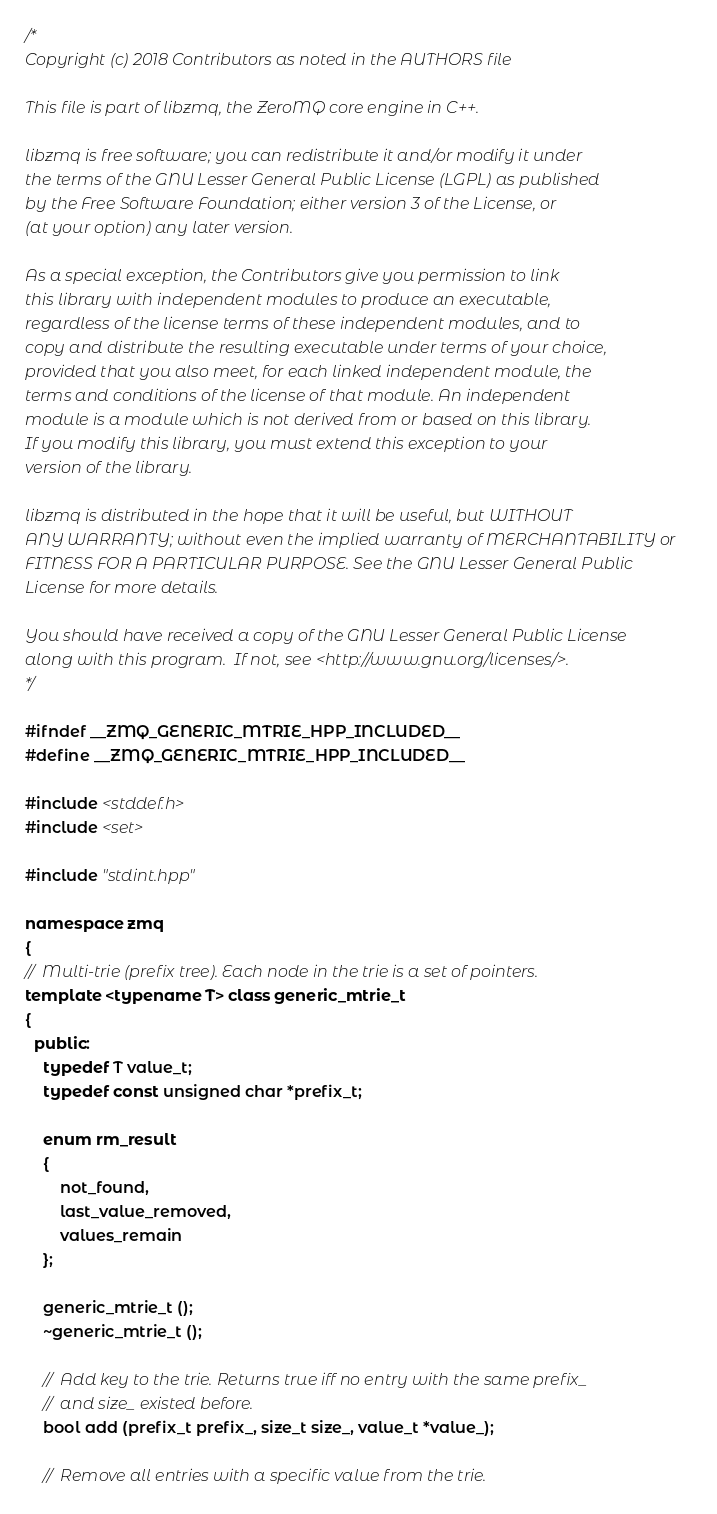Convert code to text. <code><loc_0><loc_0><loc_500><loc_500><_C++_>/*
Copyright (c) 2018 Contributors as noted in the AUTHORS file

This file is part of libzmq, the ZeroMQ core engine in C++.

libzmq is free software; you can redistribute it and/or modify it under
the terms of the GNU Lesser General Public License (LGPL) as published
by the Free Software Foundation; either version 3 of the License, or
(at your option) any later version.

As a special exception, the Contributors give you permission to link
this library with independent modules to produce an executable,
regardless of the license terms of these independent modules, and to
copy and distribute the resulting executable under terms of your choice,
provided that you also meet, for each linked independent module, the
terms and conditions of the license of that module. An independent
module is a module which is not derived from or based on this library.
If you modify this library, you must extend this exception to your
version of the library.

libzmq is distributed in the hope that it will be useful, but WITHOUT
ANY WARRANTY; without even the implied warranty of MERCHANTABILITY or
FITNESS FOR A PARTICULAR PURPOSE. See the GNU Lesser General Public
License for more details.

You should have received a copy of the GNU Lesser General Public License
along with this program.  If not, see <http://www.gnu.org/licenses/>.
*/

#ifndef __ZMQ_GENERIC_MTRIE_HPP_INCLUDED__
#define __ZMQ_GENERIC_MTRIE_HPP_INCLUDED__

#include <stddef.h>
#include <set>

#include "stdint.hpp"

namespace zmq
{
//  Multi-trie (prefix tree). Each node in the trie is a set of pointers.
template <typename T> class generic_mtrie_t
{
  public:
    typedef T value_t;
    typedef const unsigned char *prefix_t;

    enum rm_result
    {
        not_found,
        last_value_removed,
        values_remain
    };

    generic_mtrie_t ();
    ~generic_mtrie_t ();

    //  Add key to the trie. Returns true iff no entry with the same prefix_
    //  and size_ existed before.
    bool add (prefix_t prefix_, size_t size_, value_t *value_);

    //  Remove all entries with a specific value from the trie.</code> 